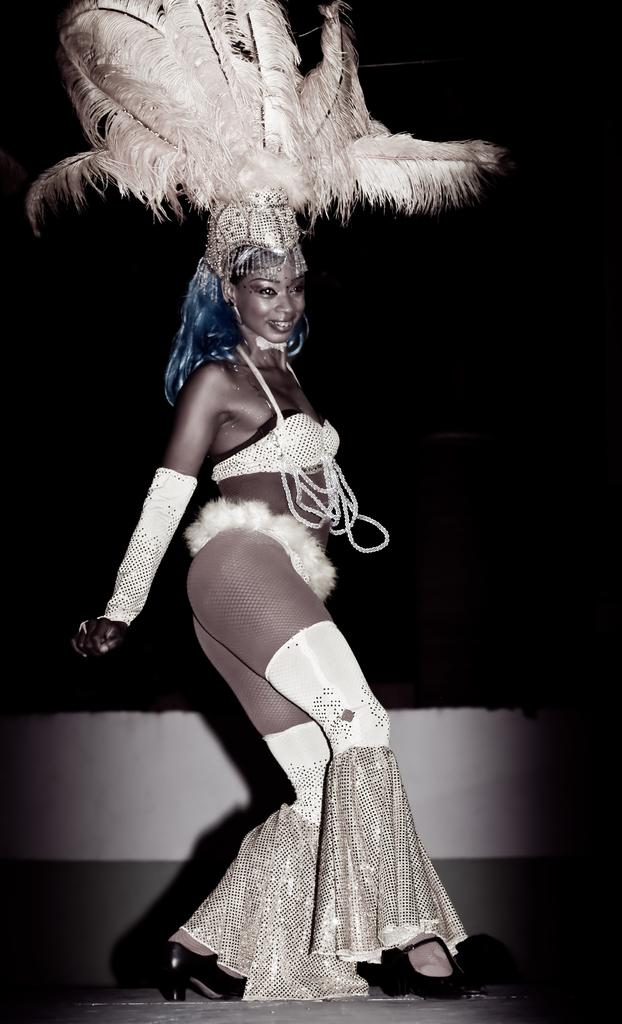Who is the main subject in the image? There is an African girl in the image. What is the girl wearing? The girl is wearing a white dress and a bird feather cap. What is the girl doing in the image? The girl is dancing on a stage. What is the color of the background in the image? The background of the image is black. Can you see any wounds on the girl's body in the image? There is no indication of any wounds on the girl's body in the image. What type of sound can be heard coming from the river in the image? There is no river present in the image, so it's not possible to determine what, if any, sounds might be heard. 